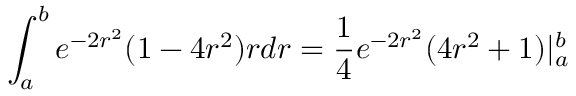Convert formula to latex. <formula><loc_0><loc_0><loc_500><loc_500>\int _ { a } ^ { b } e ^ { - 2 r ^ { 2 } } ( 1 - 4 r ^ { 2 } ) r d r = \frac { 1 } { 4 } e ^ { - 2 r ^ { 2 } } ( 4 r ^ { 2 } + 1 ) | _ { a } ^ { b }</formula> 